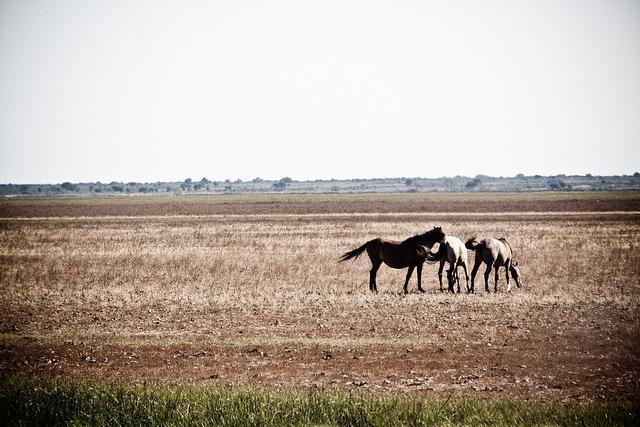How many horses?
Give a very brief answer. 3. How many people are shown?
Give a very brief answer. 0. 